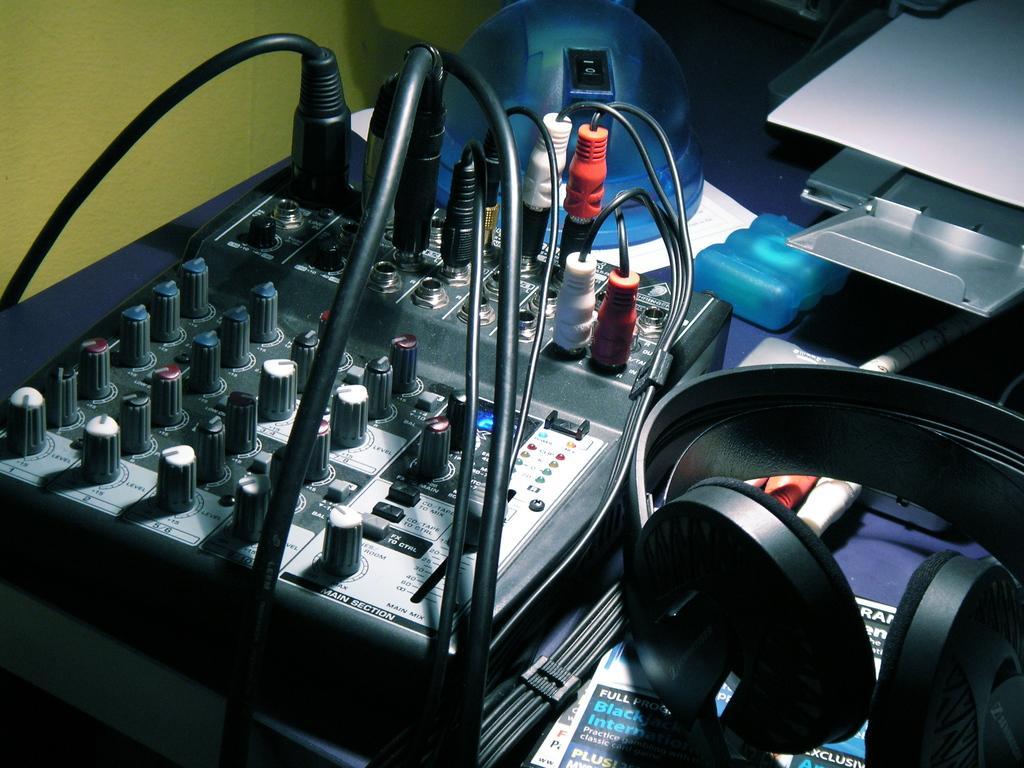Can you describe this image briefly? In this picture I can see there is an electronic device placed on a table and it has few cables attached to it. There are headset placed on the right side and there is a green wall. 